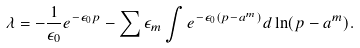<formula> <loc_0><loc_0><loc_500><loc_500>\lambda = - \frac { 1 } { \epsilon _ { 0 } } e ^ { - \epsilon _ { 0 } p } - \sum \epsilon _ { m } \int e ^ { - \epsilon _ { 0 } ( p - a ^ { m } ) } d \ln ( p - a ^ { m } ) .</formula> 